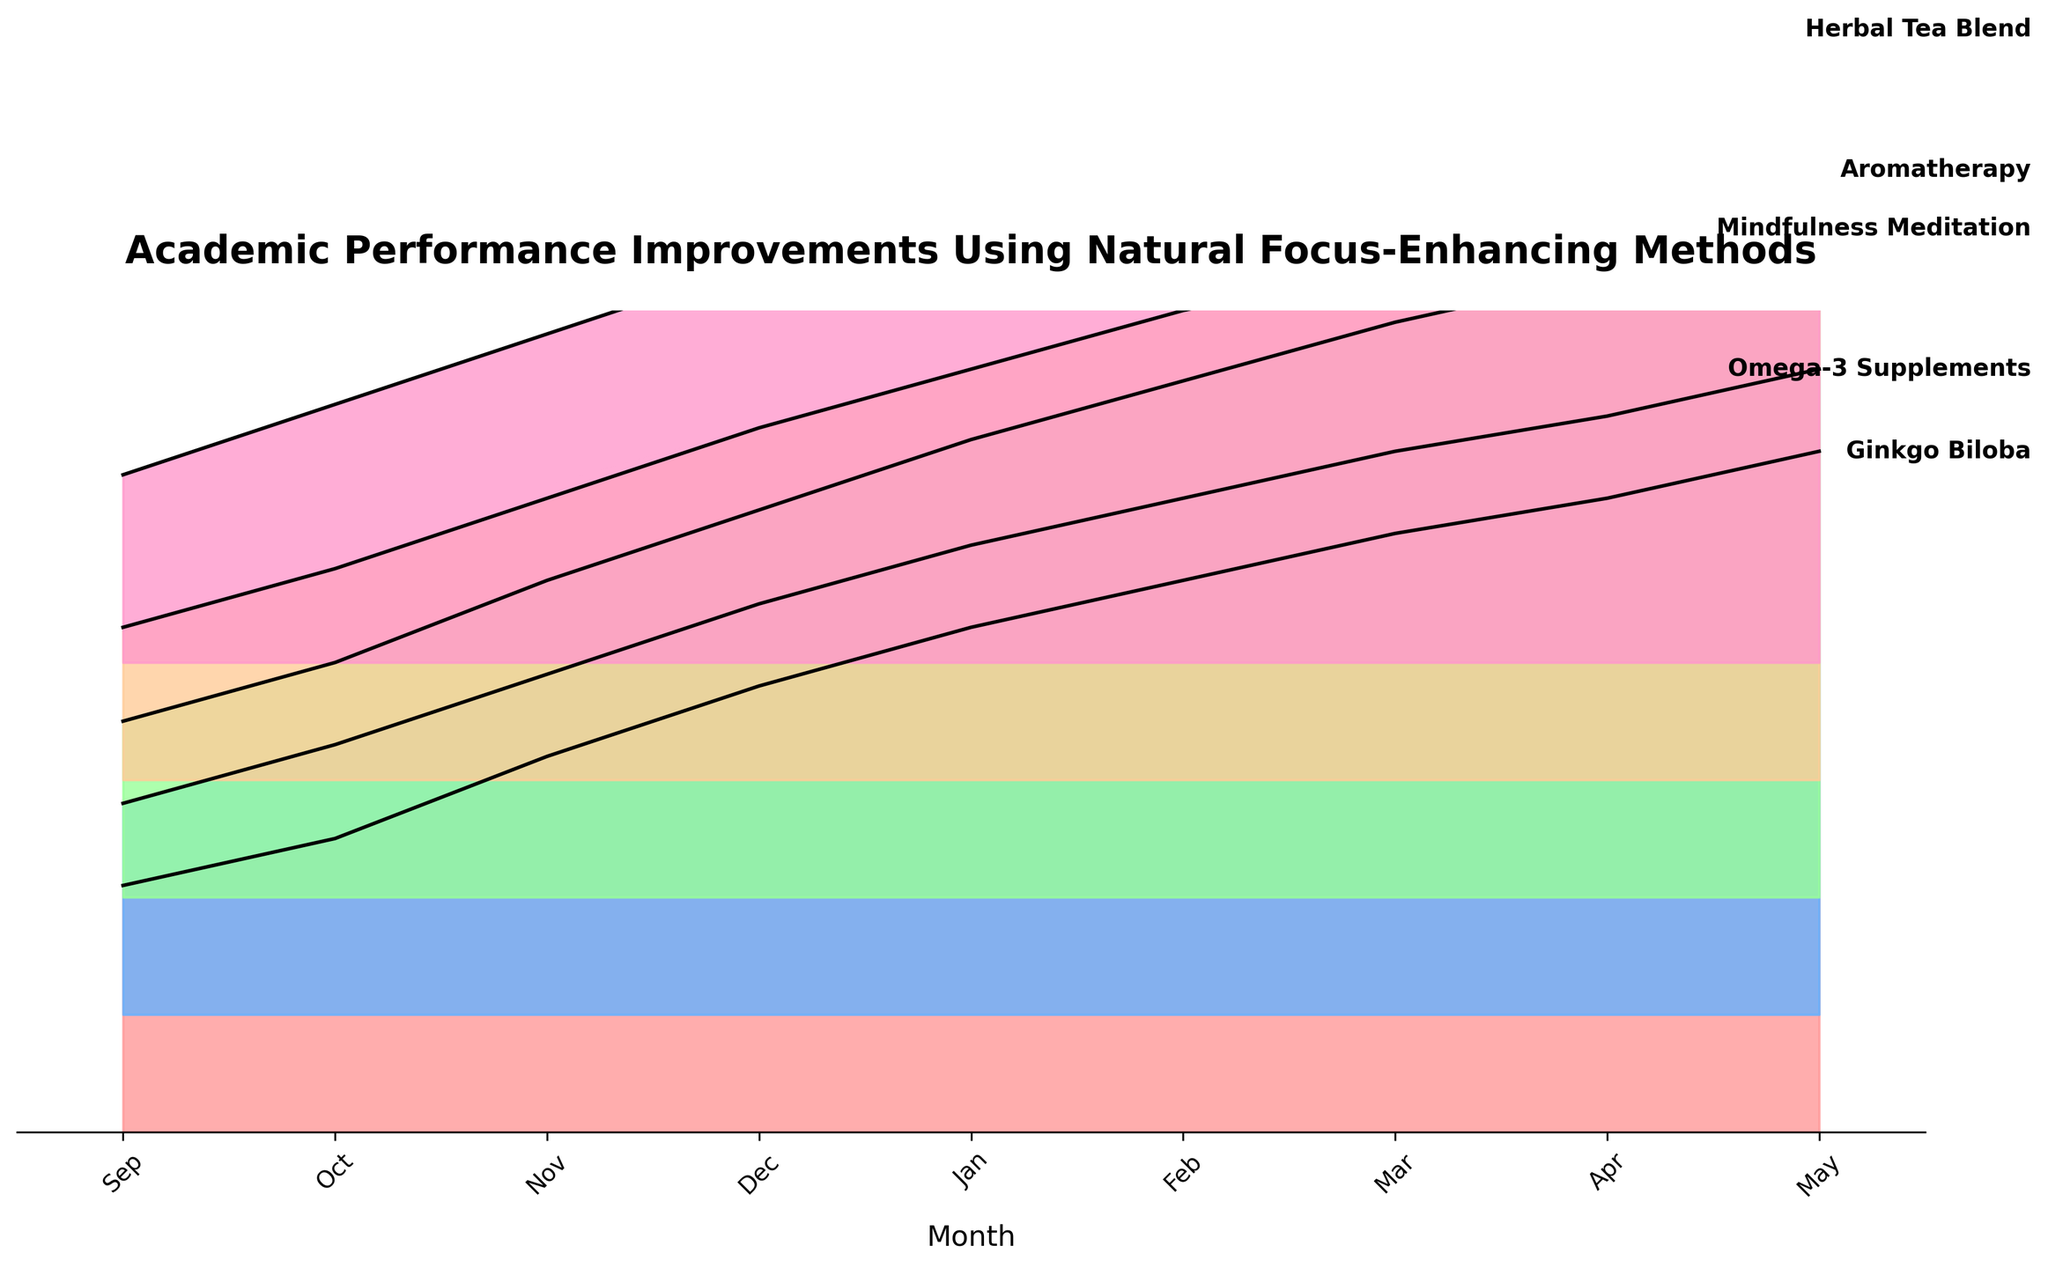what is the title of the plot? The title is usually found at the top of the plot and is meant to concisely describe what the plot is about. In this plot, the title indicates it's about the academic performance improvements using various natural focus-enhancing methods.
Answer: Academic Performance Improvements Using Natural Focus-Enhancing Methods What month shows the highest score for the Ginkgo Biloba method? To find the highest score for Ginkgo Biloba, refer to the month on the x-axis where its line reaches the highest y-axis value. In the plot, Ginkgo Biloba reaches its peak score in May.
Answer: May Which method starts with the lowest score in September? Look at the y-axis values corresponding to September for all methods, and determine which method has the lowest value. Aromatherapy has the lowest starting score in September.
Answer: Aromatherapy How many methods are compared in the plot? Count the number of distinct lines or colored patterns that represent different methods listed along the right side of the plot. There are five methods shown in the plot.
Answer: 5 What is the approximate difference in scores between Ginkgo Biloba and Omega-3 Supplements in December? Find the scores for Ginkgo Biloba and Omega-3 Supplements in December, and subtract the score of Omega-3 Supplements from the score of Ginkgo Biloba. Ginkgo Biloba has a score of 3.8 and Omega-3 Supplements have a score of 3.5, the difference is 3.8 - 3.5 = 0.3.
Answer: 0.3 Which method shows the steepest improvement between January and February? Locate the months January and February on the x-axis for each method, and observe the change in y-values. The method with the largest increase in score (steepest slope) between these two months is Ginkgo Biloba.
Answer: Ginkgo Biloba Which method achieves a score closest to 5.0 in April? In the plot, find the scores in April for each method and determine which score is nearest to 5.0. Mindfulness Meditation and Herbal Tea Blend both achieve scores closest to 5.0 in April.
Answer: Mindfulness Meditation, Herbal Tea Blend Is there any month when two methods have the exact same score? To determine this, examine each month on the x-axis and compare the scores for all methods. In April, Mindfulness Meditation and Herbal Tea Blend both have the same score of 5.0.
Answer: Yes Rank the methods based on the improvement observed from October to May. For each method, calculate the difference in scores between May and October, then rank all methods based on these differences. Rankings from highest to lowest improvement are: Ginkgo Biloba (3.3), Omega-3 Supplements (3.2), Mindfulness Meditation (3.7), Aromatherapy (3.4), Herbal Tea Blend (3.2).
Answer: Mindfulness Meditation > Aromatherapy > Ginkgo Biloba > Herbal Tea Blend = Omega-3 Supplements 